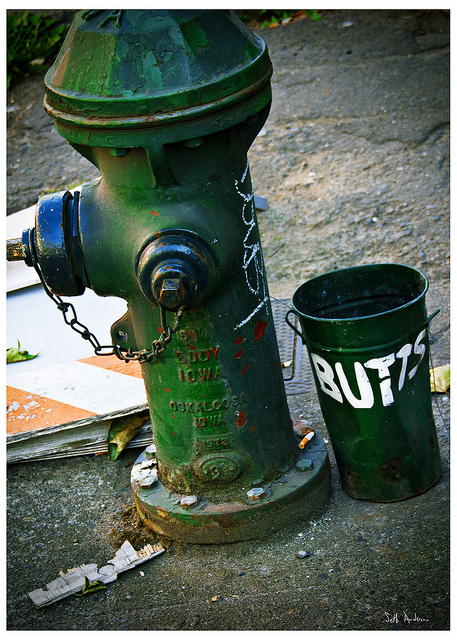Please extract the text content from this image. LOWA BUTTS OBKALOOSA 15 3 